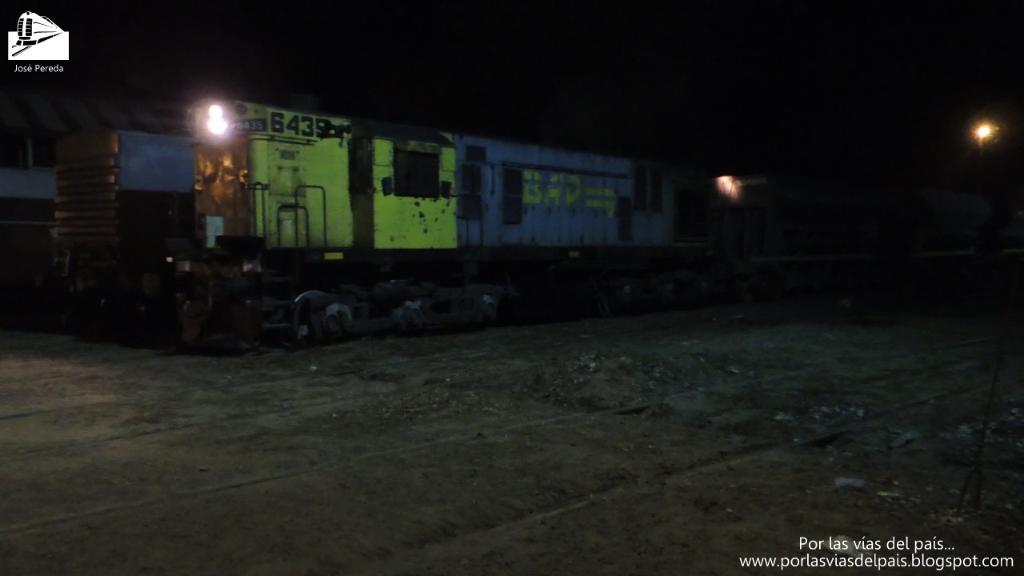What is the main subject of the image? The main subject of the image is a train. What is the train doing in the image? The train is moving on a track in the image. What feature can be seen on the train's engine? The train has a light on the engine. What can be seen in the backdrop of the image? There is a street light and a dark backdrop in the image. What type of guitar can be seen hanging on the wall in the image? There is no guitar present in the image; it features a train moving on a track. What value does the picture hold in the image? The image does not depict a picture or any value associated with it. 